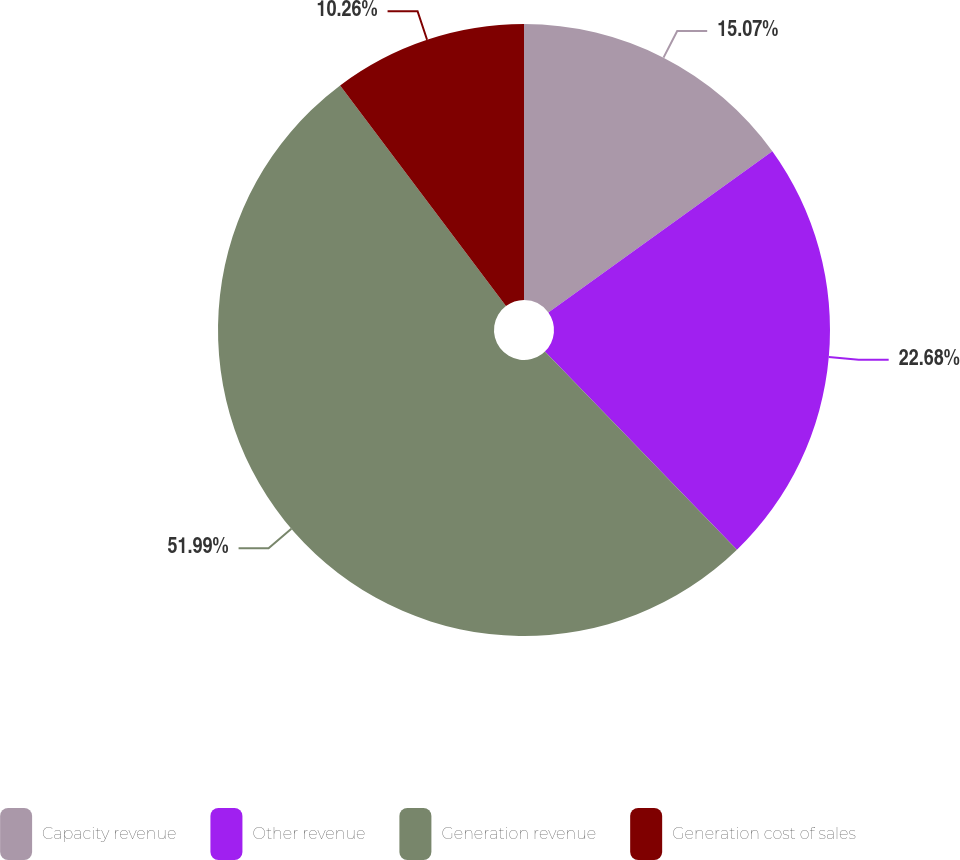Convert chart. <chart><loc_0><loc_0><loc_500><loc_500><pie_chart><fcel>Capacity revenue<fcel>Other revenue<fcel>Generation revenue<fcel>Generation cost of sales<nl><fcel>15.07%<fcel>22.68%<fcel>51.99%<fcel>10.26%<nl></chart> 